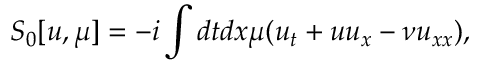<formula> <loc_0><loc_0><loc_500><loc_500>S _ { 0 } [ u , \mu ] = - i \int d t d x \mu ( u _ { t } + u u _ { x } - \nu u _ { x x } ) ,</formula> 